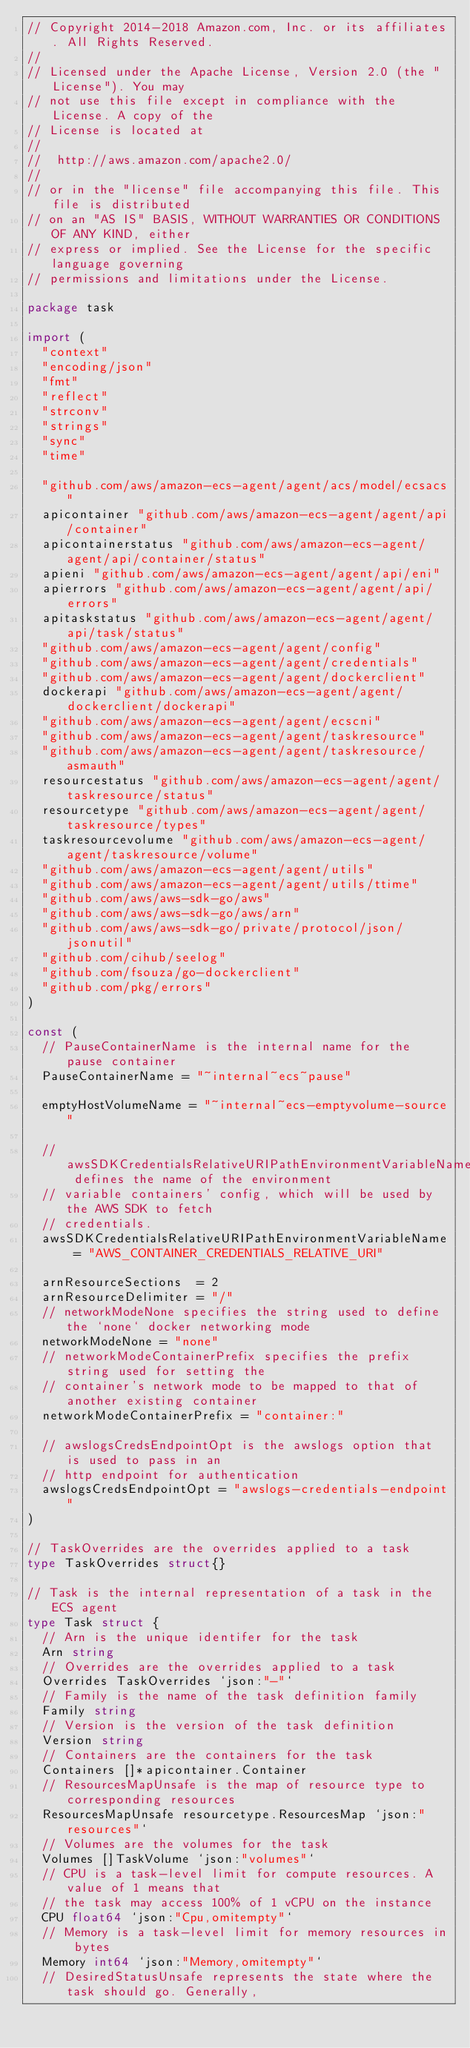Convert code to text. <code><loc_0><loc_0><loc_500><loc_500><_Go_>// Copyright 2014-2018 Amazon.com, Inc. or its affiliates. All Rights Reserved.
//
// Licensed under the Apache License, Version 2.0 (the "License"). You may
// not use this file except in compliance with the License. A copy of the
// License is located at
//
//	http://aws.amazon.com/apache2.0/
//
// or in the "license" file accompanying this file. This file is distributed
// on an "AS IS" BASIS, WITHOUT WARRANTIES OR CONDITIONS OF ANY KIND, either
// express or implied. See the License for the specific language governing
// permissions and limitations under the License.

package task

import (
	"context"
	"encoding/json"
	"fmt"
	"reflect"
	"strconv"
	"strings"
	"sync"
	"time"

	"github.com/aws/amazon-ecs-agent/agent/acs/model/ecsacs"
	apicontainer "github.com/aws/amazon-ecs-agent/agent/api/container"
	apicontainerstatus "github.com/aws/amazon-ecs-agent/agent/api/container/status"
	apieni "github.com/aws/amazon-ecs-agent/agent/api/eni"
	apierrors "github.com/aws/amazon-ecs-agent/agent/api/errors"
	apitaskstatus "github.com/aws/amazon-ecs-agent/agent/api/task/status"
	"github.com/aws/amazon-ecs-agent/agent/config"
	"github.com/aws/amazon-ecs-agent/agent/credentials"
	"github.com/aws/amazon-ecs-agent/agent/dockerclient"
	dockerapi "github.com/aws/amazon-ecs-agent/agent/dockerclient/dockerapi"
	"github.com/aws/amazon-ecs-agent/agent/ecscni"
	"github.com/aws/amazon-ecs-agent/agent/taskresource"
	"github.com/aws/amazon-ecs-agent/agent/taskresource/asmauth"
	resourcestatus "github.com/aws/amazon-ecs-agent/agent/taskresource/status"
	resourcetype "github.com/aws/amazon-ecs-agent/agent/taskresource/types"
	taskresourcevolume "github.com/aws/amazon-ecs-agent/agent/taskresource/volume"
	"github.com/aws/amazon-ecs-agent/agent/utils"
	"github.com/aws/amazon-ecs-agent/agent/utils/ttime"
	"github.com/aws/aws-sdk-go/aws"
	"github.com/aws/aws-sdk-go/aws/arn"
	"github.com/aws/aws-sdk-go/private/protocol/json/jsonutil"
	"github.com/cihub/seelog"
	"github.com/fsouza/go-dockerclient"
	"github.com/pkg/errors"
)

const (
	// PauseContainerName is the internal name for the pause container
	PauseContainerName = "~internal~ecs~pause"

	emptyHostVolumeName = "~internal~ecs-emptyvolume-source"

	// awsSDKCredentialsRelativeURIPathEnvironmentVariableName defines the name of the environment
	// variable containers' config, which will be used by the AWS SDK to fetch
	// credentials.
	awsSDKCredentialsRelativeURIPathEnvironmentVariableName = "AWS_CONTAINER_CREDENTIALS_RELATIVE_URI"

	arnResourceSections  = 2
	arnResourceDelimiter = "/"
	// networkModeNone specifies the string used to define the `none` docker networking mode
	networkModeNone = "none"
	// networkModeContainerPrefix specifies the prefix string used for setting the
	// container's network mode to be mapped to that of another existing container
	networkModeContainerPrefix = "container:"

	// awslogsCredsEndpointOpt is the awslogs option that is used to pass in an
	// http endpoint for authentication
	awslogsCredsEndpointOpt = "awslogs-credentials-endpoint"
)

// TaskOverrides are the overrides applied to a task
type TaskOverrides struct{}

// Task is the internal representation of a task in the ECS agent
type Task struct {
	// Arn is the unique identifer for the task
	Arn string
	// Overrides are the overrides applied to a task
	Overrides TaskOverrides `json:"-"`
	// Family is the name of the task definition family
	Family string
	// Version is the version of the task definition
	Version string
	// Containers are the containers for the task
	Containers []*apicontainer.Container
	// ResourcesMapUnsafe is the map of resource type to corresponding resources
	ResourcesMapUnsafe resourcetype.ResourcesMap `json:"resources"`
	// Volumes are the volumes for the task
	Volumes []TaskVolume `json:"volumes"`
	// CPU is a task-level limit for compute resources. A value of 1 means that
	// the task may access 100% of 1 vCPU on the instance
	CPU float64 `json:"Cpu,omitempty"`
	// Memory is a task-level limit for memory resources in bytes
	Memory int64 `json:"Memory,omitempty"`
	// DesiredStatusUnsafe represents the state where the task should go. Generally,</code> 